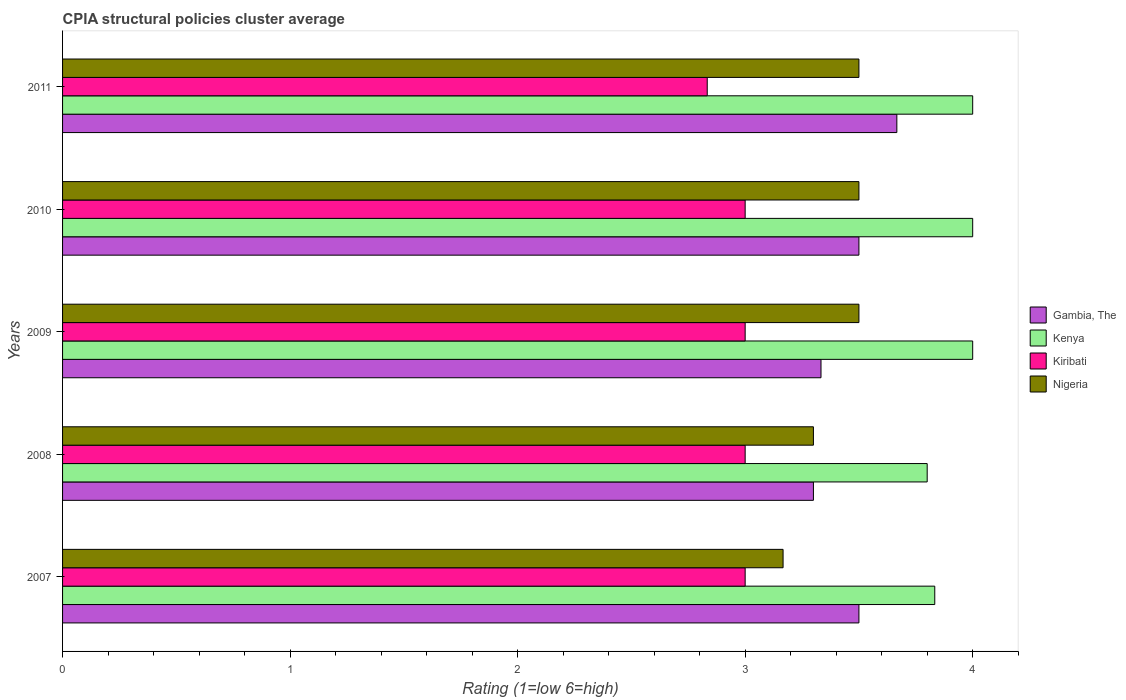How many different coloured bars are there?
Make the answer very short. 4. How many bars are there on the 1st tick from the bottom?
Keep it short and to the point. 4. What is the CPIA rating in Kiribati in 2011?
Ensure brevity in your answer.  2.83. Across all years, what is the minimum CPIA rating in Nigeria?
Your answer should be compact. 3.17. What is the difference between the CPIA rating in Gambia, The in 2008 and that in 2011?
Provide a short and direct response. -0.37. What is the average CPIA rating in Kenya per year?
Give a very brief answer. 3.93. In the year 2010, what is the difference between the CPIA rating in Nigeria and CPIA rating in Gambia, The?
Provide a short and direct response. 0. Is the CPIA rating in Nigeria in 2008 less than that in 2009?
Offer a terse response. Yes. Is the difference between the CPIA rating in Nigeria in 2008 and 2011 greater than the difference between the CPIA rating in Gambia, The in 2008 and 2011?
Your answer should be very brief. Yes. What is the difference between the highest and the second highest CPIA rating in Nigeria?
Keep it short and to the point. 0. What is the difference between the highest and the lowest CPIA rating in Gambia, The?
Offer a terse response. 0.37. In how many years, is the CPIA rating in Nigeria greater than the average CPIA rating in Nigeria taken over all years?
Make the answer very short. 3. Is it the case that in every year, the sum of the CPIA rating in Gambia, The and CPIA rating in Nigeria is greater than the sum of CPIA rating in Kiribati and CPIA rating in Kenya?
Your answer should be very brief. No. What does the 4th bar from the top in 2010 represents?
Keep it short and to the point. Gambia, The. What does the 1st bar from the bottom in 2008 represents?
Your response must be concise. Gambia, The. How many years are there in the graph?
Keep it short and to the point. 5. Are the values on the major ticks of X-axis written in scientific E-notation?
Your response must be concise. No. Where does the legend appear in the graph?
Your response must be concise. Center right. How many legend labels are there?
Ensure brevity in your answer.  4. What is the title of the graph?
Your response must be concise. CPIA structural policies cluster average. What is the label or title of the Y-axis?
Your response must be concise. Years. What is the Rating (1=low 6=high) in Gambia, The in 2007?
Ensure brevity in your answer.  3.5. What is the Rating (1=low 6=high) of Kenya in 2007?
Make the answer very short. 3.83. What is the Rating (1=low 6=high) in Kiribati in 2007?
Your answer should be very brief. 3. What is the Rating (1=low 6=high) in Nigeria in 2007?
Your answer should be very brief. 3.17. What is the Rating (1=low 6=high) of Kenya in 2008?
Make the answer very short. 3.8. What is the Rating (1=low 6=high) of Kiribati in 2008?
Keep it short and to the point. 3. What is the Rating (1=low 6=high) of Nigeria in 2008?
Offer a very short reply. 3.3. What is the Rating (1=low 6=high) in Gambia, The in 2009?
Offer a terse response. 3.33. What is the Rating (1=low 6=high) in Kenya in 2009?
Keep it short and to the point. 4. What is the Rating (1=low 6=high) in Kiribati in 2010?
Ensure brevity in your answer.  3. What is the Rating (1=low 6=high) in Gambia, The in 2011?
Offer a terse response. 3.67. What is the Rating (1=low 6=high) in Kiribati in 2011?
Give a very brief answer. 2.83. Across all years, what is the maximum Rating (1=low 6=high) of Gambia, The?
Offer a very short reply. 3.67. Across all years, what is the maximum Rating (1=low 6=high) of Kiribati?
Your answer should be compact. 3. Across all years, what is the maximum Rating (1=low 6=high) of Nigeria?
Offer a very short reply. 3.5. Across all years, what is the minimum Rating (1=low 6=high) in Kiribati?
Offer a very short reply. 2.83. Across all years, what is the minimum Rating (1=low 6=high) of Nigeria?
Make the answer very short. 3.17. What is the total Rating (1=low 6=high) in Gambia, The in the graph?
Keep it short and to the point. 17.3. What is the total Rating (1=low 6=high) of Kenya in the graph?
Your response must be concise. 19.63. What is the total Rating (1=low 6=high) in Kiribati in the graph?
Keep it short and to the point. 14.83. What is the total Rating (1=low 6=high) of Nigeria in the graph?
Your answer should be very brief. 16.97. What is the difference between the Rating (1=low 6=high) in Nigeria in 2007 and that in 2008?
Give a very brief answer. -0.13. What is the difference between the Rating (1=low 6=high) in Kiribati in 2007 and that in 2009?
Provide a succinct answer. 0. What is the difference between the Rating (1=low 6=high) in Kenya in 2007 and that in 2010?
Keep it short and to the point. -0.17. What is the difference between the Rating (1=low 6=high) in Kiribati in 2007 and that in 2011?
Offer a very short reply. 0.17. What is the difference between the Rating (1=low 6=high) in Gambia, The in 2008 and that in 2009?
Make the answer very short. -0.03. What is the difference between the Rating (1=low 6=high) in Kiribati in 2008 and that in 2009?
Provide a succinct answer. 0. What is the difference between the Rating (1=low 6=high) of Nigeria in 2008 and that in 2009?
Provide a short and direct response. -0.2. What is the difference between the Rating (1=low 6=high) of Kenya in 2008 and that in 2010?
Your answer should be compact. -0.2. What is the difference between the Rating (1=low 6=high) in Nigeria in 2008 and that in 2010?
Provide a succinct answer. -0.2. What is the difference between the Rating (1=low 6=high) in Gambia, The in 2008 and that in 2011?
Your answer should be compact. -0.37. What is the difference between the Rating (1=low 6=high) of Kenya in 2008 and that in 2011?
Your answer should be very brief. -0.2. What is the difference between the Rating (1=low 6=high) in Nigeria in 2009 and that in 2010?
Offer a very short reply. 0. What is the difference between the Rating (1=low 6=high) in Kenya in 2009 and that in 2011?
Offer a very short reply. 0. What is the difference between the Rating (1=low 6=high) in Gambia, The in 2010 and that in 2011?
Your answer should be compact. -0.17. What is the difference between the Rating (1=low 6=high) of Kenya in 2010 and that in 2011?
Your answer should be very brief. 0. What is the difference between the Rating (1=low 6=high) in Kiribati in 2010 and that in 2011?
Your answer should be very brief. 0.17. What is the difference between the Rating (1=low 6=high) in Gambia, The in 2007 and the Rating (1=low 6=high) in Kenya in 2008?
Offer a terse response. -0.3. What is the difference between the Rating (1=low 6=high) in Gambia, The in 2007 and the Rating (1=low 6=high) in Nigeria in 2008?
Ensure brevity in your answer.  0.2. What is the difference between the Rating (1=low 6=high) of Kenya in 2007 and the Rating (1=low 6=high) of Kiribati in 2008?
Offer a terse response. 0.83. What is the difference between the Rating (1=low 6=high) of Kenya in 2007 and the Rating (1=low 6=high) of Nigeria in 2008?
Your answer should be very brief. 0.53. What is the difference between the Rating (1=low 6=high) of Kiribati in 2007 and the Rating (1=low 6=high) of Nigeria in 2008?
Offer a very short reply. -0.3. What is the difference between the Rating (1=low 6=high) in Gambia, The in 2007 and the Rating (1=low 6=high) in Kenya in 2009?
Provide a short and direct response. -0.5. What is the difference between the Rating (1=low 6=high) in Gambia, The in 2007 and the Rating (1=low 6=high) in Nigeria in 2009?
Provide a short and direct response. 0. What is the difference between the Rating (1=low 6=high) in Kenya in 2007 and the Rating (1=low 6=high) in Kiribati in 2009?
Provide a short and direct response. 0.83. What is the difference between the Rating (1=low 6=high) of Kenya in 2007 and the Rating (1=low 6=high) of Nigeria in 2009?
Provide a short and direct response. 0.33. What is the difference between the Rating (1=low 6=high) in Gambia, The in 2007 and the Rating (1=low 6=high) in Nigeria in 2010?
Your response must be concise. 0. What is the difference between the Rating (1=low 6=high) in Kenya in 2007 and the Rating (1=low 6=high) in Kiribati in 2010?
Your answer should be compact. 0.83. What is the difference between the Rating (1=low 6=high) in Kenya in 2007 and the Rating (1=low 6=high) in Nigeria in 2010?
Your response must be concise. 0.33. What is the difference between the Rating (1=low 6=high) in Gambia, The in 2007 and the Rating (1=low 6=high) in Nigeria in 2011?
Give a very brief answer. 0. What is the difference between the Rating (1=low 6=high) in Kenya in 2007 and the Rating (1=low 6=high) in Kiribati in 2011?
Provide a short and direct response. 1. What is the difference between the Rating (1=low 6=high) of Kenya in 2007 and the Rating (1=low 6=high) of Nigeria in 2011?
Provide a succinct answer. 0.33. What is the difference between the Rating (1=low 6=high) of Kiribati in 2007 and the Rating (1=low 6=high) of Nigeria in 2011?
Provide a succinct answer. -0.5. What is the difference between the Rating (1=low 6=high) in Gambia, The in 2008 and the Rating (1=low 6=high) in Nigeria in 2009?
Provide a short and direct response. -0.2. What is the difference between the Rating (1=low 6=high) of Gambia, The in 2008 and the Rating (1=low 6=high) of Kenya in 2010?
Offer a very short reply. -0.7. What is the difference between the Rating (1=low 6=high) in Gambia, The in 2008 and the Rating (1=low 6=high) in Kiribati in 2010?
Give a very brief answer. 0.3. What is the difference between the Rating (1=low 6=high) in Kenya in 2008 and the Rating (1=low 6=high) in Kiribati in 2010?
Make the answer very short. 0.8. What is the difference between the Rating (1=low 6=high) in Kiribati in 2008 and the Rating (1=low 6=high) in Nigeria in 2010?
Your answer should be compact. -0.5. What is the difference between the Rating (1=low 6=high) in Gambia, The in 2008 and the Rating (1=low 6=high) in Kenya in 2011?
Give a very brief answer. -0.7. What is the difference between the Rating (1=low 6=high) in Gambia, The in 2008 and the Rating (1=low 6=high) in Kiribati in 2011?
Your response must be concise. 0.47. What is the difference between the Rating (1=low 6=high) of Gambia, The in 2008 and the Rating (1=low 6=high) of Nigeria in 2011?
Make the answer very short. -0.2. What is the difference between the Rating (1=low 6=high) of Kenya in 2008 and the Rating (1=low 6=high) of Kiribati in 2011?
Your answer should be very brief. 0.97. What is the difference between the Rating (1=low 6=high) in Kenya in 2008 and the Rating (1=low 6=high) in Nigeria in 2011?
Offer a very short reply. 0.3. What is the difference between the Rating (1=low 6=high) in Gambia, The in 2009 and the Rating (1=low 6=high) in Kenya in 2010?
Your answer should be compact. -0.67. What is the difference between the Rating (1=low 6=high) of Gambia, The in 2009 and the Rating (1=low 6=high) of Kiribati in 2010?
Give a very brief answer. 0.33. What is the difference between the Rating (1=low 6=high) in Gambia, The in 2009 and the Rating (1=low 6=high) in Kiribati in 2011?
Provide a succinct answer. 0.5. What is the difference between the Rating (1=low 6=high) in Gambia, The in 2009 and the Rating (1=low 6=high) in Nigeria in 2011?
Provide a short and direct response. -0.17. What is the difference between the Rating (1=low 6=high) in Kenya in 2009 and the Rating (1=low 6=high) in Nigeria in 2011?
Make the answer very short. 0.5. What is the difference between the Rating (1=low 6=high) of Gambia, The in 2010 and the Rating (1=low 6=high) of Nigeria in 2011?
Ensure brevity in your answer.  0. What is the difference between the Rating (1=low 6=high) of Kenya in 2010 and the Rating (1=low 6=high) of Kiribati in 2011?
Give a very brief answer. 1.17. What is the average Rating (1=low 6=high) of Gambia, The per year?
Keep it short and to the point. 3.46. What is the average Rating (1=low 6=high) of Kenya per year?
Provide a short and direct response. 3.93. What is the average Rating (1=low 6=high) of Kiribati per year?
Offer a very short reply. 2.97. What is the average Rating (1=low 6=high) in Nigeria per year?
Give a very brief answer. 3.39. In the year 2007, what is the difference between the Rating (1=low 6=high) of Kenya and Rating (1=low 6=high) of Kiribati?
Offer a terse response. 0.83. In the year 2007, what is the difference between the Rating (1=low 6=high) in Kiribati and Rating (1=low 6=high) in Nigeria?
Your answer should be very brief. -0.17. In the year 2008, what is the difference between the Rating (1=low 6=high) in Gambia, The and Rating (1=low 6=high) in Kenya?
Keep it short and to the point. -0.5. In the year 2008, what is the difference between the Rating (1=low 6=high) of Kenya and Rating (1=low 6=high) of Kiribati?
Give a very brief answer. 0.8. In the year 2009, what is the difference between the Rating (1=low 6=high) in Kiribati and Rating (1=low 6=high) in Nigeria?
Provide a short and direct response. -0.5. In the year 2010, what is the difference between the Rating (1=low 6=high) in Gambia, The and Rating (1=low 6=high) in Nigeria?
Ensure brevity in your answer.  0. In the year 2010, what is the difference between the Rating (1=low 6=high) of Kenya and Rating (1=low 6=high) of Kiribati?
Offer a terse response. 1. In the year 2011, what is the difference between the Rating (1=low 6=high) of Gambia, The and Rating (1=low 6=high) of Kenya?
Your answer should be compact. -0.33. In the year 2011, what is the difference between the Rating (1=low 6=high) in Kenya and Rating (1=low 6=high) in Nigeria?
Your answer should be compact. 0.5. What is the ratio of the Rating (1=low 6=high) of Gambia, The in 2007 to that in 2008?
Make the answer very short. 1.06. What is the ratio of the Rating (1=low 6=high) in Kenya in 2007 to that in 2008?
Keep it short and to the point. 1.01. What is the ratio of the Rating (1=low 6=high) of Kiribati in 2007 to that in 2008?
Your response must be concise. 1. What is the ratio of the Rating (1=low 6=high) in Nigeria in 2007 to that in 2008?
Keep it short and to the point. 0.96. What is the ratio of the Rating (1=low 6=high) of Kenya in 2007 to that in 2009?
Your answer should be compact. 0.96. What is the ratio of the Rating (1=low 6=high) of Nigeria in 2007 to that in 2009?
Your response must be concise. 0.9. What is the ratio of the Rating (1=low 6=high) in Kenya in 2007 to that in 2010?
Provide a short and direct response. 0.96. What is the ratio of the Rating (1=low 6=high) in Nigeria in 2007 to that in 2010?
Offer a very short reply. 0.9. What is the ratio of the Rating (1=low 6=high) in Gambia, The in 2007 to that in 2011?
Ensure brevity in your answer.  0.95. What is the ratio of the Rating (1=low 6=high) of Kiribati in 2007 to that in 2011?
Your answer should be compact. 1.06. What is the ratio of the Rating (1=low 6=high) of Nigeria in 2007 to that in 2011?
Your answer should be compact. 0.9. What is the ratio of the Rating (1=low 6=high) in Gambia, The in 2008 to that in 2009?
Ensure brevity in your answer.  0.99. What is the ratio of the Rating (1=low 6=high) in Kenya in 2008 to that in 2009?
Your answer should be very brief. 0.95. What is the ratio of the Rating (1=low 6=high) in Nigeria in 2008 to that in 2009?
Offer a very short reply. 0.94. What is the ratio of the Rating (1=low 6=high) of Gambia, The in 2008 to that in 2010?
Your answer should be compact. 0.94. What is the ratio of the Rating (1=low 6=high) in Kenya in 2008 to that in 2010?
Provide a succinct answer. 0.95. What is the ratio of the Rating (1=low 6=high) of Kiribati in 2008 to that in 2010?
Keep it short and to the point. 1. What is the ratio of the Rating (1=low 6=high) of Nigeria in 2008 to that in 2010?
Your response must be concise. 0.94. What is the ratio of the Rating (1=low 6=high) in Gambia, The in 2008 to that in 2011?
Your answer should be compact. 0.9. What is the ratio of the Rating (1=low 6=high) in Kenya in 2008 to that in 2011?
Keep it short and to the point. 0.95. What is the ratio of the Rating (1=low 6=high) of Kiribati in 2008 to that in 2011?
Offer a terse response. 1.06. What is the ratio of the Rating (1=low 6=high) of Nigeria in 2008 to that in 2011?
Offer a terse response. 0.94. What is the ratio of the Rating (1=low 6=high) in Kiribati in 2009 to that in 2010?
Provide a succinct answer. 1. What is the ratio of the Rating (1=low 6=high) of Nigeria in 2009 to that in 2010?
Your answer should be compact. 1. What is the ratio of the Rating (1=low 6=high) of Kenya in 2009 to that in 2011?
Keep it short and to the point. 1. What is the ratio of the Rating (1=low 6=high) in Kiribati in 2009 to that in 2011?
Provide a succinct answer. 1.06. What is the ratio of the Rating (1=low 6=high) of Gambia, The in 2010 to that in 2011?
Offer a very short reply. 0.95. What is the ratio of the Rating (1=low 6=high) in Kenya in 2010 to that in 2011?
Ensure brevity in your answer.  1. What is the ratio of the Rating (1=low 6=high) of Kiribati in 2010 to that in 2011?
Make the answer very short. 1.06. What is the ratio of the Rating (1=low 6=high) of Nigeria in 2010 to that in 2011?
Your answer should be very brief. 1. What is the difference between the highest and the second highest Rating (1=low 6=high) of Gambia, The?
Offer a very short reply. 0.17. What is the difference between the highest and the lowest Rating (1=low 6=high) of Gambia, The?
Offer a terse response. 0.37. What is the difference between the highest and the lowest Rating (1=low 6=high) of Kenya?
Your answer should be compact. 0.2. 